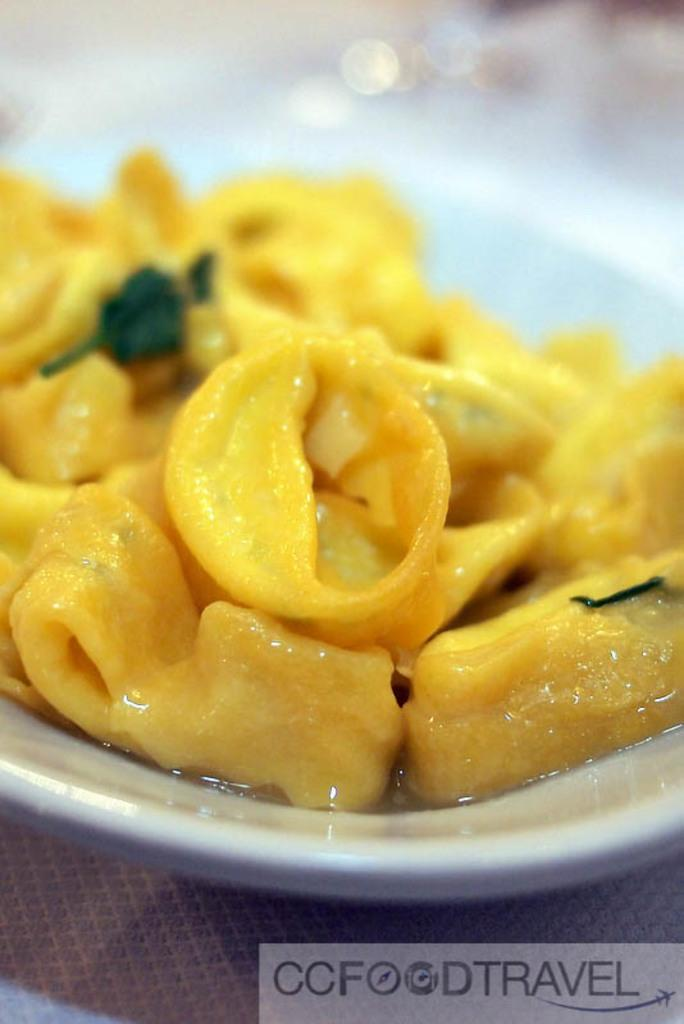What is on the plate in the image? There is a food item in a plate in the image. What is the plate resting on? The plate is on an object. Is there any text or logo visible in the image? Yes, there is a watermark at the bottom of the image. How would you describe the background of the image? The background of the image is blurred. What type of shirt is the goat wearing in the image? There is no goat or shirt present in the image. Is the food item in the image shaped like a square? The shape of the food item is not mentioned in the facts, so we cannot determine if it is shaped like a square. 